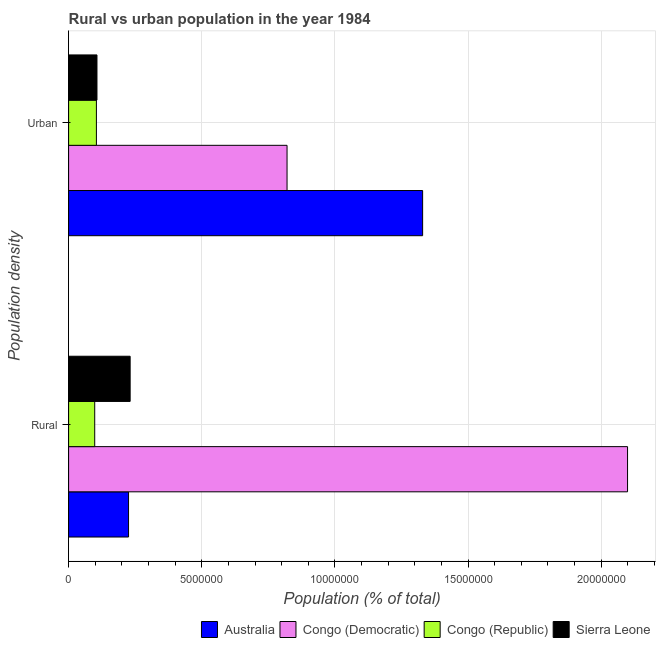What is the label of the 2nd group of bars from the top?
Ensure brevity in your answer.  Rural. What is the urban population density in Australia?
Provide a short and direct response. 1.33e+07. Across all countries, what is the maximum urban population density?
Your answer should be compact. 1.33e+07. Across all countries, what is the minimum urban population density?
Your answer should be compact. 1.04e+06. In which country was the rural population density minimum?
Offer a terse response. Congo (Republic). What is the total urban population density in the graph?
Offer a terse response. 2.36e+07. What is the difference between the urban population density in Congo (Democratic) and that in Australia?
Provide a short and direct response. -5.09e+06. What is the difference between the rural population density in Congo (Republic) and the urban population density in Congo (Democratic)?
Your answer should be compact. -7.22e+06. What is the average urban population density per country?
Provide a short and direct response. 5.90e+06. What is the difference between the urban population density and rural population density in Sierra Leone?
Make the answer very short. -1.25e+06. What is the ratio of the urban population density in Sierra Leone to that in Australia?
Keep it short and to the point. 0.08. What does the 2nd bar from the top in Urban represents?
Offer a terse response. Congo (Republic). What does the 2nd bar from the bottom in Urban represents?
Keep it short and to the point. Congo (Democratic). Does the graph contain any zero values?
Keep it short and to the point. No. Does the graph contain grids?
Your response must be concise. Yes. What is the title of the graph?
Keep it short and to the point. Rural vs urban population in the year 1984. Does "High income" appear as one of the legend labels in the graph?
Ensure brevity in your answer.  No. What is the label or title of the X-axis?
Your response must be concise. Population (% of total). What is the label or title of the Y-axis?
Give a very brief answer. Population density. What is the Population (% of total) in Australia in Rural?
Offer a terse response. 2.25e+06. What is the Population (% of total) in Congo (Democratic) in Rural?
Your response must be concise. 2.10e+07. What is the Population (% of total) in Congo (Republic) in Rural?
Offer a terse response. 9.81e+05. What is the Population (% of total) of Sierra Leone in Rural?
Keep it short and to the point. 2.31e+06. What is the Population (% of total) of Australia in Urban?
Keep it short and to the point. 1.33e+07. What is the Population (% of total) of Congo (Democratic) in Urban?
Make the answer very short. 8.20e+06. What is the Population (% of total) in Congo (Republic) in Urban?
Ensure brevity in your answer.  1.04e+06. What is the Population (% of total) of Sierra Leone in Urban?
Give a very brief answer. 1.07e+06. Across all Population density, what is the maximum Population (% of total) of Australia?
Keep it short and to the point. 1.33e+07. Across all Population density, what is the maximum Population (% of total) of Congo (Democratic)?
Make the answer very short. 2.10e+07. Across all Population density, what is the maximum Population (% of total) of Congo (Republic)?
Keep it short and to the point. 1.04e+06. Across all Population density, what is the maximum Population (% of total) in Sierra Leone?
Ensure brevity in your answer.  2.31e+06. Across all Population density, what is the minimum Population (% of total) of Australia?
Provide a short and direct response. 2.25e+06. Across all Population density, what is the minimum Population (% of total) of Congo (Democratic)?
Provide a short and direct response. 8.20e+06. Across all Population density, what is the minimum Population (% of total) of Congo (Republic)?
Give a very brief answer. 9.81e+05. Across all Population density, what is the minimum Population (% of total) in Sierra Leone?
Your answer should be very brief. 1.07e+06. What is the total Population (% of total) in Australia in the graph?
Your answer should be very brief. 1.55e+07. What is the total Population (% of total) in Congo (Democratic) in the graph?
Ensure brevity in your answer.  2.92e+07. What is the total Population (% of total) of Congo (Republic) in the graph?
Make the answer very short. 2.03e+06. What is the total Population (% of total) in Sierra Leone in the graph?
Give a very brief answer. 3.38e+06. What is the difference between the Population (% of total) of Australia in Rural and that in Urban?
Offer a very short reply. -1.10e+07. What is the difference between the Population (% of total) of Congo (Democratic) in Rural and that in Urban?
Your answer should be compact. 1.28e+07. What is the difference between the Population (% of total) in Congo (Republic) in Rural and that in Urban?
Keep it short and to the point. -6.32e+04. What is the difference between the Population (% of total) in Sierra Leone in Rural and that in Urban?
Offer a terse response. 1.25e+06. What is the difference between the Population (% of total) in Australia in Rural and the Population (% of total) in Congo (Democratic) in Urban?
Provide a succinct answer. -5.95e+06. What is the difference between the Population (% of total) of Australia in Rural and the Population (% of total) of Congo (Republic) in Urban?
Your answer should be compact. 1.21e+06. What is the difference between the Population (% of total) of Australia in Rural and the Population (% of total) of Sierra Leone in Urban?
Give a very brief answer. 1.19e+06. What is the difference between the Population (% of total) of Congo (Democratic) in Rural and the Population (% of total) of Congo (Republic) in Urban?
Ensure brevity in your answer.  1.99e+07. What is the difference between the Population (% of total) of Congo (Democratic) in Rural and the Population (% of total) of Sierra Leone in Urban?
Give a very brief answer. 1.99e+07. What is the difference between the Population (% of total) in Congo (Republic) in Rural and the Population (% of total) in Sierra Leone in Urban?
Give a very brief answer. -8.43e+04. What is the average Population (% of total) in Australia per Population density?
Provide a short and direct response. 7.77e+06. What is the average Population (% of total) of Congo (Democratic) per Population density?
Your response must be concise. 1.46e+07. What is the average Population (% of total) in Congo (Republic) per Population density?
Your answer should be very brief. 1.01e+06. What is the average Population (% of total) of Sierra Leone per Population density?
Give a very brief answer. 1.69e+06. What is the difference between the Population (% of total) in Australia and Population (% of total) in Congo (Democratic) in Rural?
Give a very brief answer. -1.87e+07. What is the difference between the Population (% of total) in Australia and Population (% of total) in Congo (Republic) in Rural?
Provide a short and direct response. 1.27e+06. What is the difference between the Population (% of total) of Australia and Population (% of total) of Sierra Leone in Rural?
Your answer should be very brief. -6.02e+04. What is the difference between the Population (% of total) of Congo (Democratic) and Population (% of total) of Congo (Republic) in Rural?
Your response must be concise. 2.00e+07. What is the difference between the Population (% of total) in Congo (Democratic) and Population (% of total) in Sierra Leone in Rural?
Offer a terse response. 1.87e+07. What is the difference between the Population (% of total) of Congo (Republic) and Population (% of total) of Sierra Leone in Rural?
Give a very brief answer. -1.33e+06. What is the difference between the Population (% of total) in Australia and Population (% of total) in Congo (Democratic) in Urban?
Your response must be concise. 5.09e+06. What is the difference between the Population (% of total) of Australia and Population (% of total) of Congo (Republic) in Urban?
Your answer should be compact. 1.22e+07. What is the difference between the Population (% of total) in Australia and Population (% of total) in Sierra Leone in Urban?
Offer a very short reply. 1.22e+07. What is the difference between the Population (% of total) of Congo (Democratic) and Population (% of total) of Congo (Republic) in Urban?
Offer a terse response. 7.16e+06. What is the difference between the Population (% of total) of Congo (Democratic) and Population (% of total) of Sierra Leone in Urban?
Your answer should be very brief. 7.14e+06. What is the difference between the Population (% of total) in Congo (Republic) and Population (% of total) in Sierra Leone in Urban?
Provide a short and direct response. -2.12e+04. What is the ratio of the Population (% of total) of Australia in Rural to that in Urban?
Your answer should be compact. 0.17. What is the ratio of the Population (% of total) of Congo (Democratic) in Rural to that in Urban?
Provide a succinct answer. 2.56. What is the ratio of the Population (% of total) of Congo (Republic) in Rural to that in Urban?
Your response must be concise. 0.94. What is the ratio of the Population (% of total) in Sierra Leone in Rural to that in Urban?
Your answer should be compact. 2.17. What is the difference between the highest and the second highest Population (% of total) in Australia?
Make the answer very short. 1.10e+07. What is the difference between the highest and the second highest Population (% of total) of Congo (Democratic)?
Ensure brevity in your answer.  1.28e+07. What is the difference between the highest and the second highest Population (% of total) in Congo (Republic)?
Ensure brevity in your answer.  6.32e+04. What is the difference between the highest and the second highest Population (% of total) in Sierra Leone?
Provide a succinct answer. 1.25e+06. What is the difference between the highest and the lowest Population (% of total) of Australia?
Your answer should be compact. 1.10e+07. What is the difference between the highest and the lowest Population (% of total) of Congo (Democratic)?
Provide a short and direct response. 1.28e+07. What is the difference between the highest and the lowest Population (% of total) of Congo (Republic)?
Your response must be concise. 6.32e+04. What is the difference between the highest and the lowest Population (% of total) of Sierra Leone?
Offer a very short reply. 1.25e+06. 